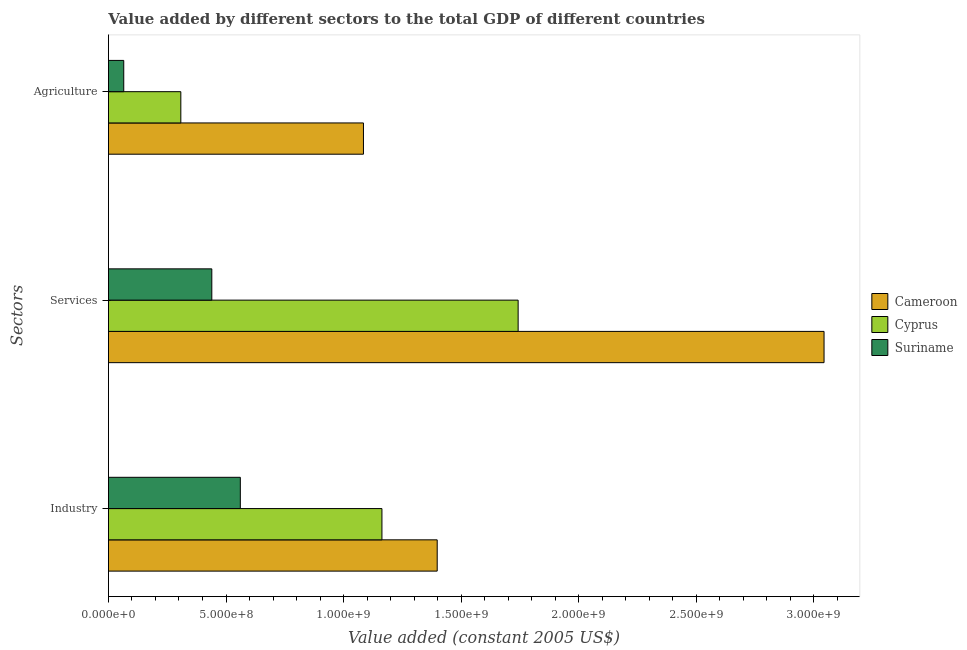How many different coloured bars are there?
Your answer should be compact. 3. How many bars are there on the 2nd tick from the top?
Ensure brevity in your answer.  3. What is the label of the 1st group of bars from the top?
Your answer should be very brief. Agriculture. What is the value added by agricultural sector in Cameroon?
Offer a terse response. 1.08e+09. Across all countries, what is the maximum value added by services?
Your response must be concise. 3.04e+09. Across all countries, what is the minimum value added by industrial sector?
Your answer should be very brief. 5.61e+08. In which country was the value added by agricultural sector maximum?
Your answer should be compact. Cameroon. In which country was the value added by services minimum?
Ensure brevity in your answer.  Suriname. What is the total value added by agricultural sector in the graph?
Offer a terse response. 1.46e+09. What is the difference between the value added by services in Cyprus and that in Suriname?
Ensure brevity in your answer.  1.30e+09. What is the difference between the value added by agricultural sector in Suriname and the value added by services in Cameroon?
Your answer should be compact. -2.98e+09. What is the average value added by services per country?
Provide a short and direct response. 1.74e+09. What is the difference between the value added by agricultural sector and value added by services in Cyprus?
Ensure brevity in your answer.  -1.43e+09. In how many countries, is the value added by agricultural sector greater than 1400000000 US$?
Your answer should be very brief. 0. What is the ratio of the value added by services in Cameroon to that in Suriname?
Keep it short and to the point. 6.92. Is the value added by services in Cyprus less than that in Cameroon?
Provide a short and direct response. Yes. What is the difference between the highest and the second highest value added by services?
Your answer should be very brief. 1.30e+09. What is the difference between the highest and the lowest value added by industrial sector?
Offer a very short reply. 8.37e+08. What does the 2nd bar from the top in Industry represents?
Provide a succinct answer. Cyprus. What does the 2nd bar from the bottom in Services represents?
Your answer should be compact. Cyprus. How many bars are there?
Your answer should be very brief. 9. Are all the bars in the graph horizontal?
Your answer should be compact. Yes. How many countries are there in the graph?
Make the answer very short. 3. Are the values on the major ticks of X-axis written in scientific E-notation?
Your answer should be compact. Yes. Does the graph contain any zero values?
Your response must be concise. No. Does the graph contain grids?
Keep it short and to the point. No. How are the legend labels stacked?
Make the answer very short. Vertical. What is the title of the graph?
Ensure brevity in your answer.  Value added by different sectors to the total GDP of different countries. Does "Cabo Verde" appear as one of the legend labels in the graph?
Offer a terse response. No. What is the label or title of the X-axis?
Ensure brevity in your answer.  Value added (constant 2005 US$). What is the label or title of the Y-axis?
Provide a succinct answer. Sectors. What is the Value added (constant 2005 US$) of Cameroon in Industry?
Your answer should be compact. 1.40e+09. What is the Value added (constant 2005 US$) of Cyprus in Industry?
Offer a very short reply. 1.16e+09. What is the Value added (constant 2005 US$) of Suriname in Industry?
Make the answer very short. 5.61e+08. What is the Value added (constant 2005 US$) of Cameroon in Services?
Offer a terse response. 3.04e+09. What is the Value added (constant 2005 US$) of Cyprus in Services?
Ensure brevity in your answer.  1.74e+09. What is the Value added (constant 2005 US$) in Suriname in Services?
Give a very brief answer. 4.40e+08. What is the Value added (constant 2005 US$) of Cameroon in Agriculture?
Your answer should be very brief. 1.08e+09. What is the Value added (constant 2005 US$) of Cyprus in Agriculture?
Offer a very short reply. 3.08e+08. What is the Value added (constant 2005 US$) of Suriname in Agriculture?
Offer a terse response. 6.51e+07. Across all Sectors, what is the maximum Value added (constant 2005 US$) in Cameroon?
Your answer should be very brief. 3.04e+09. Across all Sectors, what is the maximum Value added (constant 2005 US$) of Cyprus?
Your response must be concise. 1.74e+09. Across all Sectors, what is the maximum Value added (constant 2005 US$) of Suriname?
Provide a short and direct response. 5.61e+08. Across all Sectors, what is the minimum Value added (constant 2005 US$) in Cameroon?
Offer a terse response. 1.08e+09. Across all Sectors, what is the minimum Value added (constant 2005 US$) in Cyprus?
Offer a very short reply. 3.08e+08. Across all Sectors, what is the minimum Value added (constant 2005 US$) in Suriname?
Keep it short and to the point. 6.51e+07. What is the total Value added (constant 2005 US$) in Cameroon in the graph?
Your answer should be compact. 5.53e+09. What is the total Value added (constant 2005 US$) in Cyprus in the graph?
Ensure brevity in your answer.  3.21e+09. What is the total Value added (constant 2005 US$) of Suriname in the graph?
Offer a terse response. 1.07e+09. What is the difference between the Value added (constant 2005 US$) in Cameroon in Industry and that in Services?
Your response must be concise. -1.64e+09. What is the difference between the Value added (constant 2005 US$) of Cyprus in Industry and that in Services?
Make the answer very short. -5.79e+08. What is the difference between the Value added (constant 2005 US$) of Suriname in Industry and that in Services?
Give a very brief answer. 1.21e+08. What is the difference between the Value added (constant 2005 US$) of Cameroon in Industry and that in Agriculture?
Offer a very short reply. 3.14e+08. What is the difference between the Value added (constant 2005 US$) of Cyprus in Industry and that in Agriculture?
Provide a succinct answer. 8.55e+08. What is the difference between the Value added (constant 2005 US$) of Suriname in Industry and that in Agriculture?
Provide a short and direct response. 4.96e+08. What is the difference between the Value added (constant 2005 US$) in Cameroon in Services and that in Agriculture?
Ensure brevity in your answer.  1.96e+09. What is the difference between the Value added (constant 2005 US$) in Cyprus in Services and that in Agriculture?
Provide a succinct answer. 1.43e+09. What is the difference between the Value added (constant 2005 US$) of Suriname in Services and that in Agriculture?
Provide a succinct answer. 3.74e+08. What is the difference between the Value added (constant 2005 US$) of Cameroon in Industry and the Value added (constant 2005 US$) of Cyprus in Services?
Provide a short and direct response. -3.44e+08. What is the difference between the Value added (constant 2005 US$) of Cameroon in Industry and the Value added (constant 2005 US$) of Suriname in Services?
Make the answer very short. 9.58e+08. What is the difference between the Value added (constant 2005 US$) of Cyprus in Industry and the Value added (constant 2005 US$) of Suriname in Services?
Your response must be concise. 7.23e+08. What is the difference between the Value added (constant 2005 US$) in Cameroon in Industry and the Value added (constant 2005 US$) in Cyprus in Agriculture?
Offer a very short reply. 1.09e+09. What is the difference between the Value added (constant 2005 US$) of Cameroon in Industry and the Value added (constant 2005 US$) of Suriname in Agriculture?
Your answer should be very brief. 1.33e+09. What is the difference between the Value added (constant 2005 US$) of Cyprus in Industry and the Value added (constant 2005 US$) of Suriname in Agriculture?
Make the answer very short. 1.10e+09. What is the difference between the Value added (constant 2005 US$) of Cameroon in Services and the Value added (constant 2005 US$) of Cyprus in Agriculture?
Make the answer very short. 2.74e+09. What is the difference between the Value added (constant 2005 US$) of Cameroon in Services and the Value added (constant 2005 US$) of Suriname in Agriculture?
Offer a very short reply. 2.98e+09. What is the difference between the Value added (constant 2005 US$) of Cyprus in Services and the Value added (constant 2005 US$) of Suriname in Agriculture?
Keep it short and to the point. 1.68e+09. What is the average Value added (constant 2005 US$) of Cameroon per Sectors?
Provide a short and direct response. 1.84e+09. What is the average Value added (constant 2005 US$) in Cyprus per Sectors?
Offer a very short reply. 1.07e+09. What is the average Value added (constant 2005 US$) of Suriname per Sectors?
Your answer should be very brief. 3.55e+08. What is the difference between the Value added (constant 2005 US$) in Cameroon and Value added (constant 2005 US$) in Cyprus in Industry?
Your response must be concise. 2.35e+08. What is the difference between the Value added (constant 2005 US$) in Cameroon and Value added (constant 2005 US$) in Suriname in Industry?
Your response must be concise. 8.37e+08. What is the difference between the Value added (constant 2005 US$) in Cyprus and Value added (constant 2005 US$) in Suriname in Industry?
Your response must be concise. 6.02e+08. What is the difference between the Value added (constant 2005 US$) in Cameroon and Value added (constant 2005 US$) in Cyprus in Services?
Provide a short and direct response. 1.30e+09. What is the difference between the Value added (constant 2005 US$) in Cameroon and Value added (constant 2005 US$) in Suriname in Services?
Keep it short and to the point. 2.60e+09. What is the difference between the Value added (constant 2005 US$) in Cyprus and Value added (constant 2005 US$) in Suriname in Services?
Your answer should be very brief. 1.30e+09. What is the difference between the Value added (constant 2005 US$) of Cameroon and Value added (constant 2005 US$) of Cyprus in Agriculture?
Give a very brief answer. 7.77e+08. What is the difference between the Value added (constant 2005 US$) in Cameroon and Value added (constant 2005 US$) in Suriname in Agriculture?
Keep it short and to the point. 1.02e+09. What is the difference between the Value added (constant 2005 US$) in Cyprus and Value added (constant 2005 US$) in Suriname in Agriculture?
Offer a very short reply. 2.43e+08. What is the ratio of the Value added (constant 2005 US$) in Cameroon in Industry to that in Services?
Ensure brevity in your answer.  0.46. What is the ratio of the Value added (constant 2005 US$) in Cyprus in Industry to that in Services?
Offer a terse response. 0.67. What is the ratio of the Value added (constant 2005 US$) of Suriname in Industry to that in Services?
Provide a succinct answer. 1.28. What is the ratio of the Value added (constant 2005 US$) in Cameroon in Industry to that in Agriculture?
Your answer should be very brief. 1.29. What is the ratio of the Value added (constant 2005 US$) in Cyprus in Industry to that in Agriculture?
Give a very brief answer. 3.78. What is the ratio of the Value added (constant 2005 US$) in Suriname in Industry to that in Agriculture?
Your response must be concise. 8.61. What is the ratio of the Value added (constant 2005 US$) in Cameroon in Services to that in Agriculture?
Ensure brevity in your answer.  2.81. What is the ratio of the Value added (constant 2005 US$) in Cyprus in Services to that in Agriculture?
Offer a very short reply. 5.66. What is the ratio of the Value added (constant 2005 US$) in Suriname in Services to that in Agriculture?
Keep it short and to the point. 6.75. What is the difference between the highest and the second highest Value added (constant 2005 US$) in Cameroon?
Provide a succinct answer. 1.64e+09. What is the difference between the highest and the second highest Value added (constant 2005 US$) of Cyprus?
Provide a succinct answer. 5.79e+08. What is the difference between the highest and the second highest Value added (constant 2005 US$) of Suriname?
Give a very brief answer. 1.21e+08. What is the difference between the highest and the lowest Value added (constant 2005 US$) in Cameroon?
Your answer should be very brief. 1.96e+09. What is the difference between the highest and the lowest Value added (constant 2005 US$) in Cyprus?
Provide a succinct answer. 1.43e+09. What is the difference between the highest and the lowest Value added (constant 2005 US$) in Suriname?
Offer a terse response. 4.96e+08. 